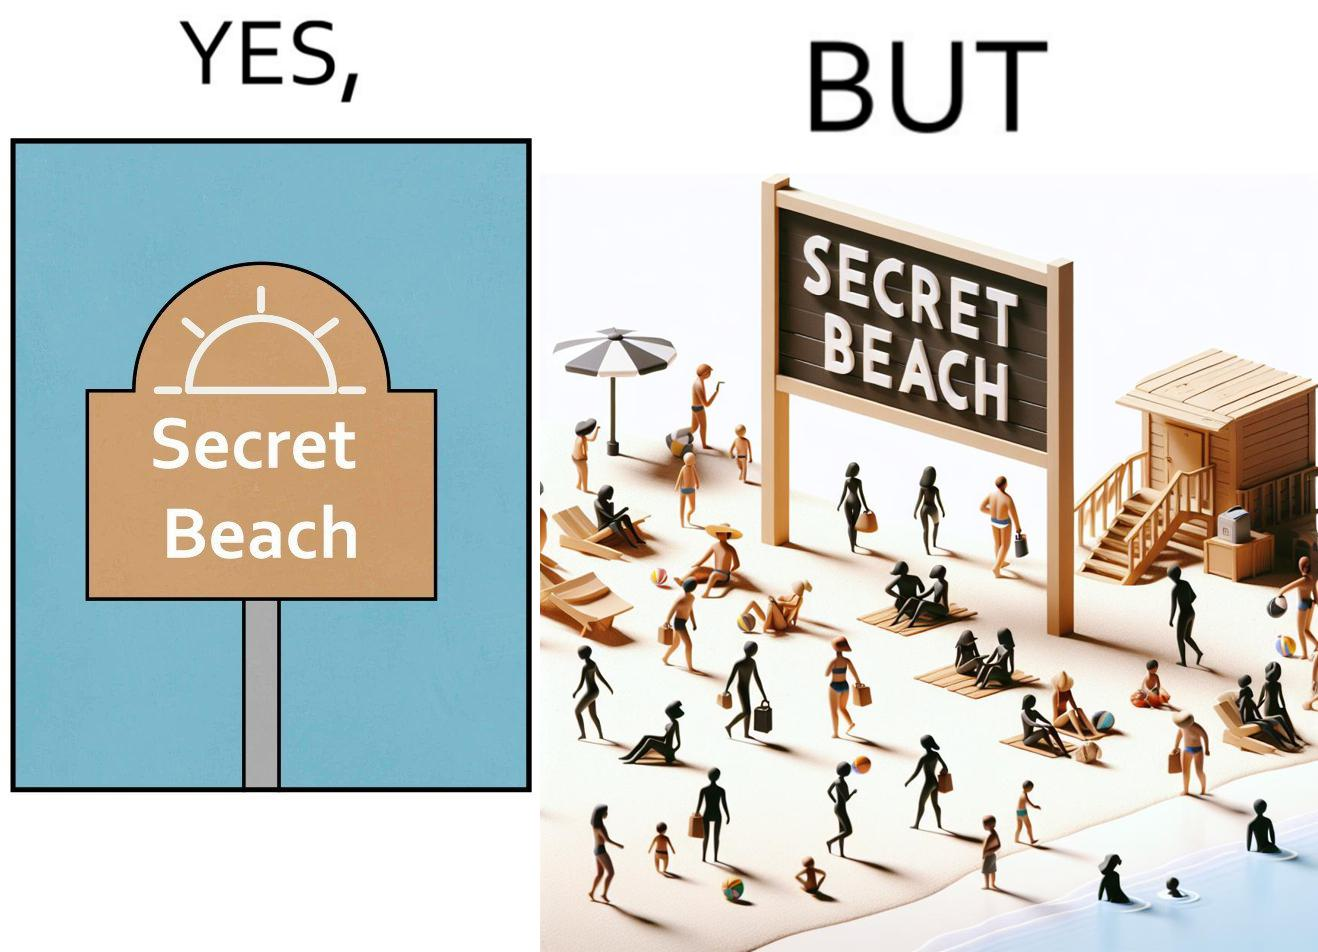Describe what you see in this image. The image is ironical, as people can be seen in the beach, and is clearly not a secret, while the board at the entrance has "Secret Beach" written on it. 